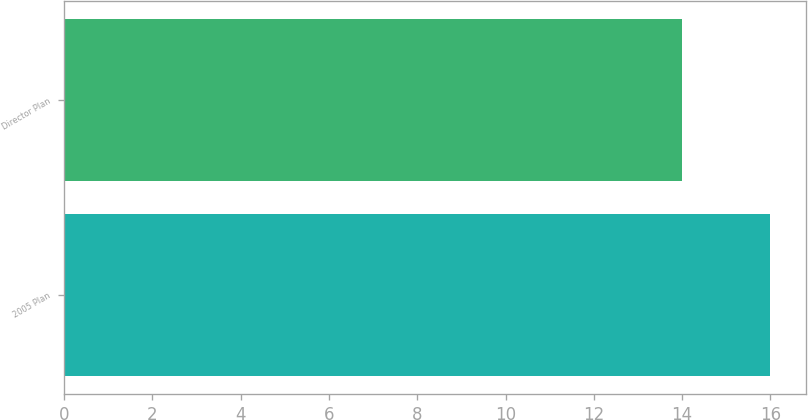Convert chart to OTSL. <chart><loc_0><loc_0><loc_500><loc_500><bar_chart><fcel>2005 Plan<fcel>Director Plan<nl><fcel>16<fcel>14<nl></chart> 